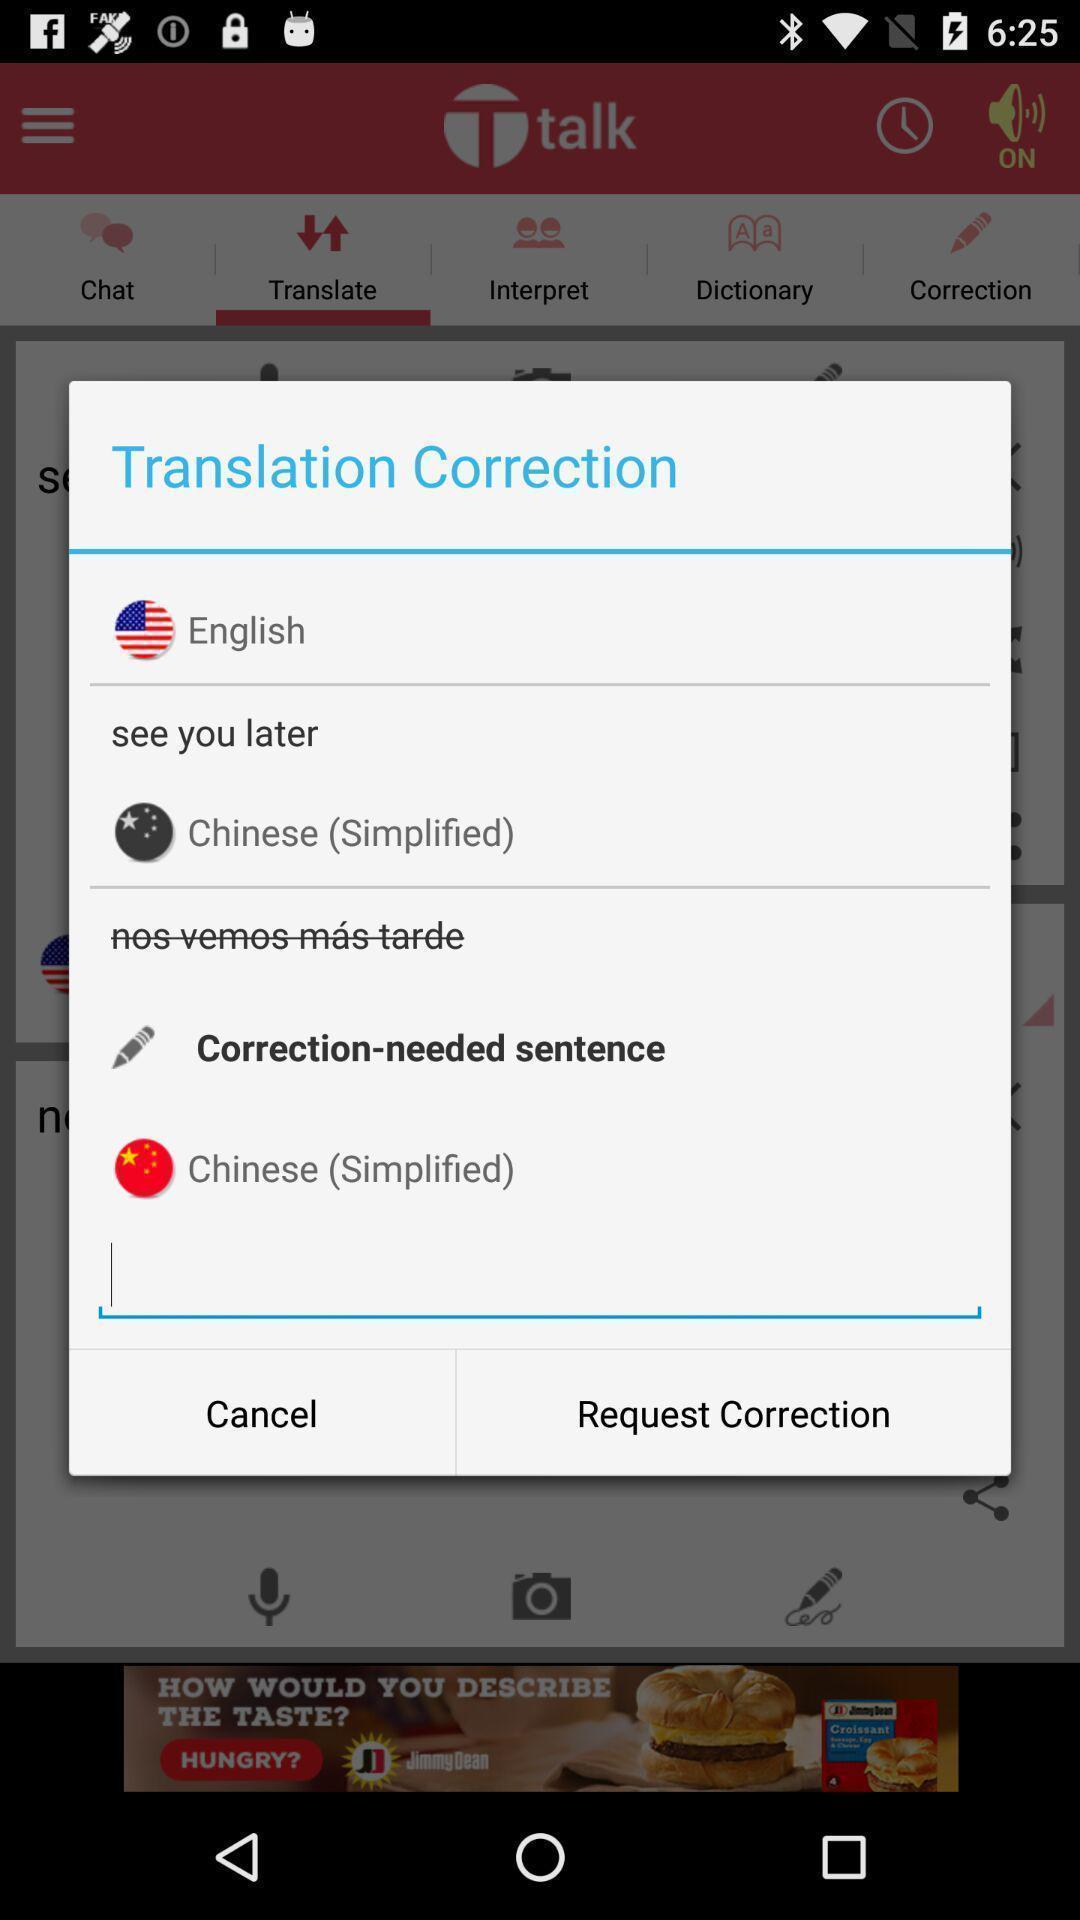What is the overall content of this screenshot? Pop-up for translation correction. 